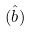Convert formula to latex. <formula><loc_0><loc_0><loc_500><loc_500>( \hat { b } )</formula> 